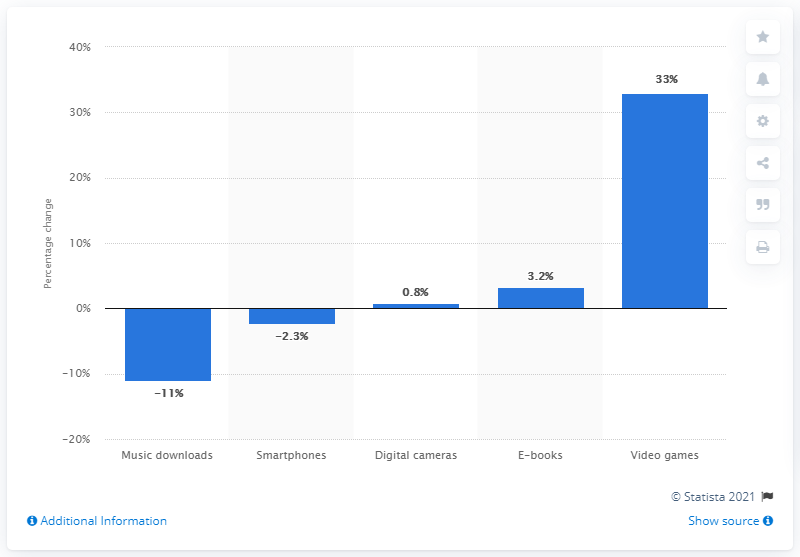Draw attention to some important aspects in this diagram. In 2017, the rate of increase of digital books in Italy was 3.2%. 